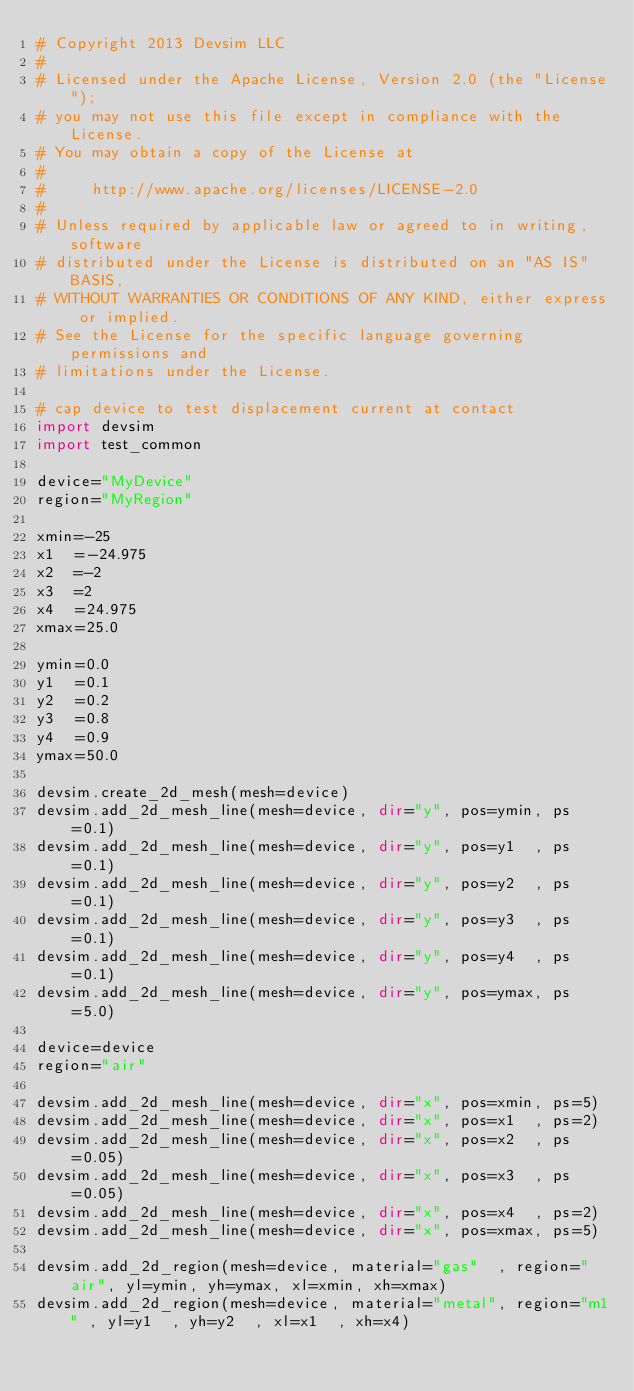<code> <loc_0><loc_0><loc_500><loc_500><_Python_># Copyright 2013 Devsim LLC
#
# Licensed under the Apache License, Version 2.0 (the "License");
# you may not use this file except in compliance with the License.
# You may obtain a copy of the License at
#
#     http://www.apache.org/licenses/LICENSE-2.0
#
# Unless required by applicable law or agreed to in writing, software
# distributed under the License is distributed on an "AS IS" BASIS,
# WITHOUT WARRANTIES OR CONDITIONS OF ANY KIND, either express or implied.
# See the License for the specific language governing permissions and
# limitations under the License.

# cap device to test displacement current at contact
import devsim
import test_common

device="MyDevice"
region="MyRegion"

xmin=-25
x1  =-24.975
x2  =-2
x3  =2
x4  =24.975
xmax=25.0

ymin=0.0
y1  =0.1
y2  =0.2
y3  =0.8
y4  =0.9
ymax=50.0

devsim.create_2d_mesh(mesh=device)
devsim.add_2d_mesh_line(mesh=device, dir="y", pos=ymin, ps=0.1)
devsim.add_2d_mesh_line(mesh=device, dir="y", pos=y1  , ps=0.1)
devsim.add_2d_mesh_line(mesh=device, dir="y", pos=y2  , ps=0.1)
devsim.add_2d_mesh_line(mesh=device, dir="y", pos=y3  , ps=0.1)
devsim.add_2d_mesh_line(mesh=device, dir="y", pos=y4  , ps=0.1)
devsim.add_2d_mesh_line(mesh=device, dir="y", pos=ymax, ps=5.0)

device=device
region="air"

devsim.add_2d_mesh_line(mesh=device, dir="x", pos=xmin, ps=5)
devsim.add_2d_mesh_line(mesh=device, dir="x", pos=x1  , ps=2)
devsim.add_2d_mesh_line(mesh=device, dir="x", pos=x2  , ps=0.05)
devsim.add_2d_mesh_line(mesh=device, dir="x", pos=x3  , ps=0.05)
devsim.add_2d_mesh_line(mesh=device, dir="x", pos=x4  , ps=2)
devsim.add_2d_mesh_line(mesh=device, dir="x", pos=xmax, ps=5)

devsim.add_2d_region(mesh=device, material="gas"  , region="air", yl=ymin, yh=ymax, xl=xmin, xh=xmax)
devsim.add_2d_region(mesh=device, material="metal", region="m1" , yl=y1  , yh=y2  , xl=x1  , xh=x4)</code> 